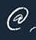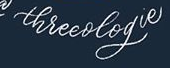What words are shown in these images in order, separated by a semicolon? @; threeologie 